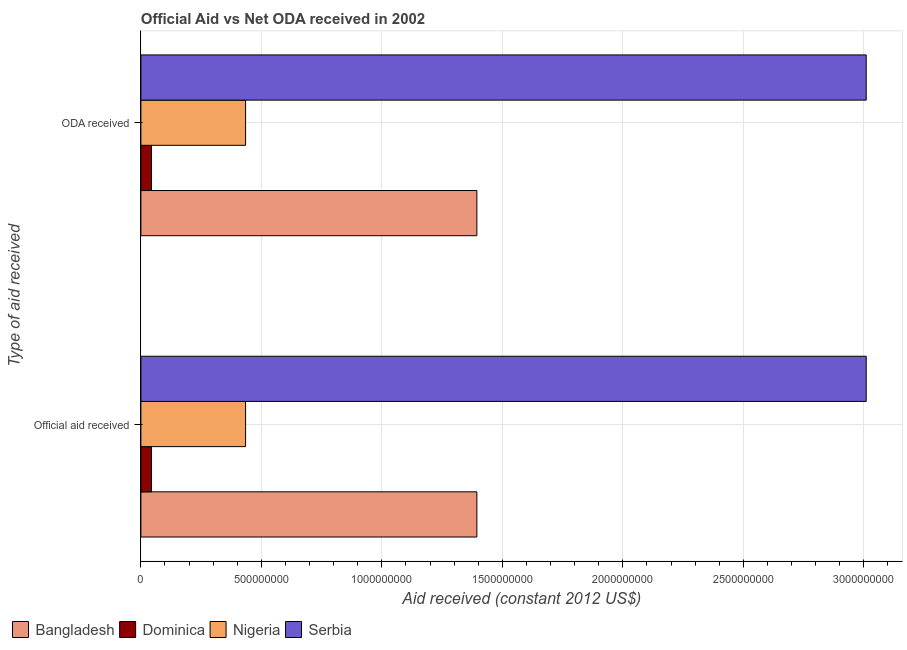How many different coloured bars are there?
Your answer should be compact. 4. Are the number of bars per tick equal to the number of legend labels?
Your answer should be compact. Yes. How many bars are there on the 1st tick from the top?
Provide a succinct answer. 4. How many bars are there on the 2nd tick from the bottom?
Keep it short and to the point. 4. What is the label of the 1st group of bars from the top?
Provide a succinct answer. ODA received. What is the oda received in Nigeria?
Keep it short and to the point. 4.34e+08. Across all countries, what is the maximum official aid received?
Give a very brief answer. 3.01e+09. Across all countries, what is the minimum oda received?
Provide a short and direct response. 4.40e+07. In which country was the official aid received maximum?
Ensure brevity in your answer.  Serbia. In which country was the official aid received minimum?
Give a very brief answer. Dominica. What is the total oda received in the graph?
Your answer should be very brief. 4.88e+09. What is the difference between the official aid received in Bangladesh and that in Serbia?
Make the answer very short. -1.62e+09. What is the difference between the official aid received in Nigeria and the oda received in Serbia?
Provide a succinct answer. -2.58e+09. What is the average oda received per country?
Provide a short and direct response. 1.22e+09. What is the ratio of the official aid received in Dominica to that in Serbia?
Your answer should be very brief. 0.01. What does the 4th bar from the top in Official aid received represents?
Offer a very short reply. Bangladesh. What does the 3rd bar from the bottom in ODA received represents?
Your answer should be very brief. Nigeria. Are the values on the major ticks of X-axis written in scientific E-notation?
Your answer should be compact. No. Does the graph contain any zero values?
Your response must be concise. No. Where does the legend appear in the graph?
Ensure brevity in your answer.  Bottom left. How many legend labels are there?
Offer a very short reply. 4. What is the title of the graph?
Offer a terse response. Official Aid vs Net ODA received in 2002 . Does "Singapore" appear as one of the legend labels in the graph?
Your response must be concise. No. What is the label or title of the X-axis?
Provide a short and direct response. Aid received (constant 2012 US$). What is the label or title of the Y-axis?
Offer a terse response. Type of aid received. What is the Aid received (constant 2012 US$) of Bangladesh in Official aid received?
Offer a very short reply. 1.39e+09. What is the Aid received (constant 2012 US$) in Dominica in Official aid received?
Make the answer very short. 4.40e+07. What is the Aid received (constant 2012 US$) of Nigeria in Official aid received?
Give a very brief answer. 4.34e+08. What is the Aid received (constant 2012 US$) in Serbia in Official aid received?
Your response must be concise. 3.01e+09. What is the Aid received (constant 2012 US$) of Bangladesh in ODA received?
Ensure brevity in your answer.  1.39e+09. What is the Aid received (constant 2012 US$) in Dominica in ODA received?
Your response must be concise. 4.40e+07. What is the Aid received (constant 2012 US$) in Nigeria in ODA received?
Your answer should be compact. 4.34e+08. What is the Aid received (constant 2012 US$) in Serbia in ODA received?
Ensure brevity in your answer.  3.01e+09. Across all Type of aid received, what is the maximum Aid received (constant 2012 US$) in Bangladesh?
Provide a succinct answer. 1.39e+09. Across all Type of aid received, what is the maximum Aid received (constant 2012 US$) in Dominica?
Your response must be concise. 4.40e+07. Across all Type of aid received, what is the maximum Aid received (constant 2012 US$) in Nigeria?
Your answer should be very brief. 4.34e+08. Across all Type of aid received, what is the maximum Aid received (constant 2012 US$) in Serbia?
Give a very brief answer. 3.01e+09. Across all Type of aid received, what is the minimum Aid received (constant 2012 US$) in Bangladesh?
Keep it short and to the point. 1.39e+09. Across all Type of aid received, what is the minimum Aid received (constant 2012 US$) of Dominica?
Offer a very short reply. 4.40e+07. Across all Type of aid received, what is the minimum Aid received (constant 2012 US$) in Nigeria?
Give a very brief answer. 4.34e+08. Across all Type of aid received, what is the minimum Aid received (constant 2012 US$) in Serbia?
Keep it short and to the point. 3.01e+09. What is the total Aid received (constant 2012 US$) of Bangladesh in the graph?
Give a very brief answer. 2.79e+09. What is the total Aid received (constant 2012 US$) in Dominica in the graph?
Give a very brief answer. 8.80e+07. What is the total Aid received (constant 2012 US$) in Nigeria in the graph?
Provide a succinct answer. 8.69e+08. What is the total Aid received (constant 2012 US$) in Serbia in the graph?
Your answer should be compact. 6.02e+09. What is the difference between the Aid received (constant 2012 US$) in Bangladesh in Official aid received and that in ODA received?
Ensure brevity in your answer.  0. What is the difference between the Aid received (constant 2012 US$) in Dominica in Official aid received and that in ODA received?
Keep it short and to the point. 0. What is the difference between the Aid received (constant 2012 US$) of Serbia in Official aid received and that in ODA received?
Your response must be concise. 0. What is the difference between the Aid received (constant 2012 US$) of Bangladesh in Official aid received and the Aid received (constant 2012 US$) of Dominica in ODA received?
Provide a succinct answer. 1.35e+09. What is the difference between the Aid received (constant 2012 US$) in Bangladesh in Official aid received and the Aid received (constant 2012 US$) in Nigeria in ODA received?
Provide a succinct answer. 9.60e+08. What is the difference between the Aid received (constant 2012 US$) of Bangladesh in Official aid received and the Aid received (constant 2012 US$) of Serbia in ODA received?
Provide a short and direct response. -1.62e+09. What is the difference between the Aid received (constant 2012 US$) in Dominica in Official aid received and the Aid received (constant 2012 US$) in Nigeria in ODA received?
Your answer should be compact. -3.90e+08. What is the difference between the Aid received (constant 2012 US$) in Dominica in Official aid received and the Aid received (constant 2012 US$) in Serbia in ODA received?
Provide a succinct answer. -2.97e+09. What is the difference between the Aid received (constant 2012 US$) of Nigeria in Official aid received and the Aid received (constant 2012 US$) of Serbia in ODA received?
Offer a terse response. -2.58e+09. What is the average Aid received (constant 2012 US$) in Bangladesh per Type of aid received?
Your response must be concise. 1.39e+09. What is the average Aid received (constant 2012 US$) of Dominica per Type of aid received?
Make the answer very short. 4.40e+07. What is the average Aid received (constant 2012 US$) of Nigeria per Type of aid received?
Your answer should be very brief. 4.34e+08. What is the average Aid received (constant 2012 US$) in Serbia per Type of aid received?
Make the answer very short. 3.01e+09. What is the difference between the Aid received (constant 2012 US$) of Bangladesh and Aid received (constant 2012 US$) of Dominica in Official aid received?
Provide a succinct answer. 1.35e+09. What is the difference between the Aid received (constant 2012 US$) of Bangladesh and Aid received (constant 2012 US$) of Nigeria in Official aid received?
Provide a short and direct response. 9.60e+08. What is the difference between the Aid received (constant 2012 US$) of Bangladesh and Aid received (constant 2012 US$) of Serbia in Official aid received?
Offer a very short reply. -1.62e+09. What is the difference between the Aid received (constant 2012 US$) of Dominica and Aid received (constant 2012 US$) of Nigeria in Official aid received?
Your answer should be very brief. -3.90e+08. What is the difference between the Aid received (constant 2012 US$) in Dominica and Aid received (constant 2012 US$) in Serbia in Official aid received?
Provide a succinct answer. -2.97e+09. What is the difference between the Aid received (constant 2012 US$) in Nigeria and Aid received (constant 2012 US$) in Serbia in Official aid received?
Offer a very short reply. -2.58e+09. What is the difference between the Aid received (constant 2012 US$) in Bangladesh and Aid received (constant 2012 US$) in Dominica in ODA received?
Provide a succinct answer. 1.35e+09. What is the difference between the Aid received (constant 2012 US$) of Bangladesh and Aid received (constant 2012 US$) of Nigeria in ODA received?
Offer a terse response. 9.60e+08. What is the difference between the Aid received (constant 2012 US$) in Bangladesh and Aid received (constant 2012 US$) in Serbia in ODA received?
Make the answer very short. -1.62e+09. What is the difference between the Aid received (constant 2012 US$) in Dominica and Aid received (constant 2012 US$) in Nigeria in ODA received?
Provide a short and direct response. -3.90e+08. What is the difference between the Aid received (constant 2012 US$) of Dominica and Aid received (constant 2012 US$) of Serbia in ODA received?
Your answer should be compact. -2.97e+09. What is the difference between the Aid received (constant 2012 US$) of Nigeria and Aid received (constant 2012 US$) of Serbia in ODA received?
Give a very brief answer. -2.58e+09. What is the ratio of the Aid received (constant 2012 US$) in Dominica in Official aid received to that in ODA received?
Offer a very short reply. 1. What is the difference between the highest and the second highest Aid received (constant 2012 US$) in Dominica?
Provide a short and direct response. 0. What is the difference between the highest and the second highest Aid received (constant 2012 US$) of Serbia?
Provide a succinct answer. 0. What is the difference between the highest and the lowest Aid received (constant 2012 US$) in Dominica?
Your response must be concise. 0. What is the difference between the highest and the lowest Aid received (constant 2012 US$) in Nigeria?
Your response must be concise. 0. 